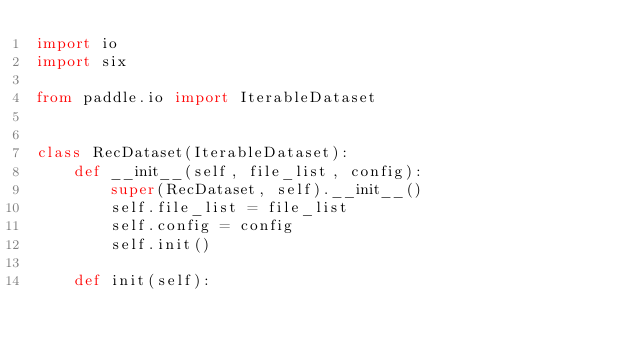Convert code to text. <code><loc_0><loc_0><loc_500><loc_500><_Python_>import io
import six

from paddle.io import IterableDataset


class RecDataset(IterableDataset):
    def __init__(self, file_list, config):
        super(RecDataset, self).__init__()
        self.file_list = file_list
        self.config = config
        self.init()

    def init(self):</code> 